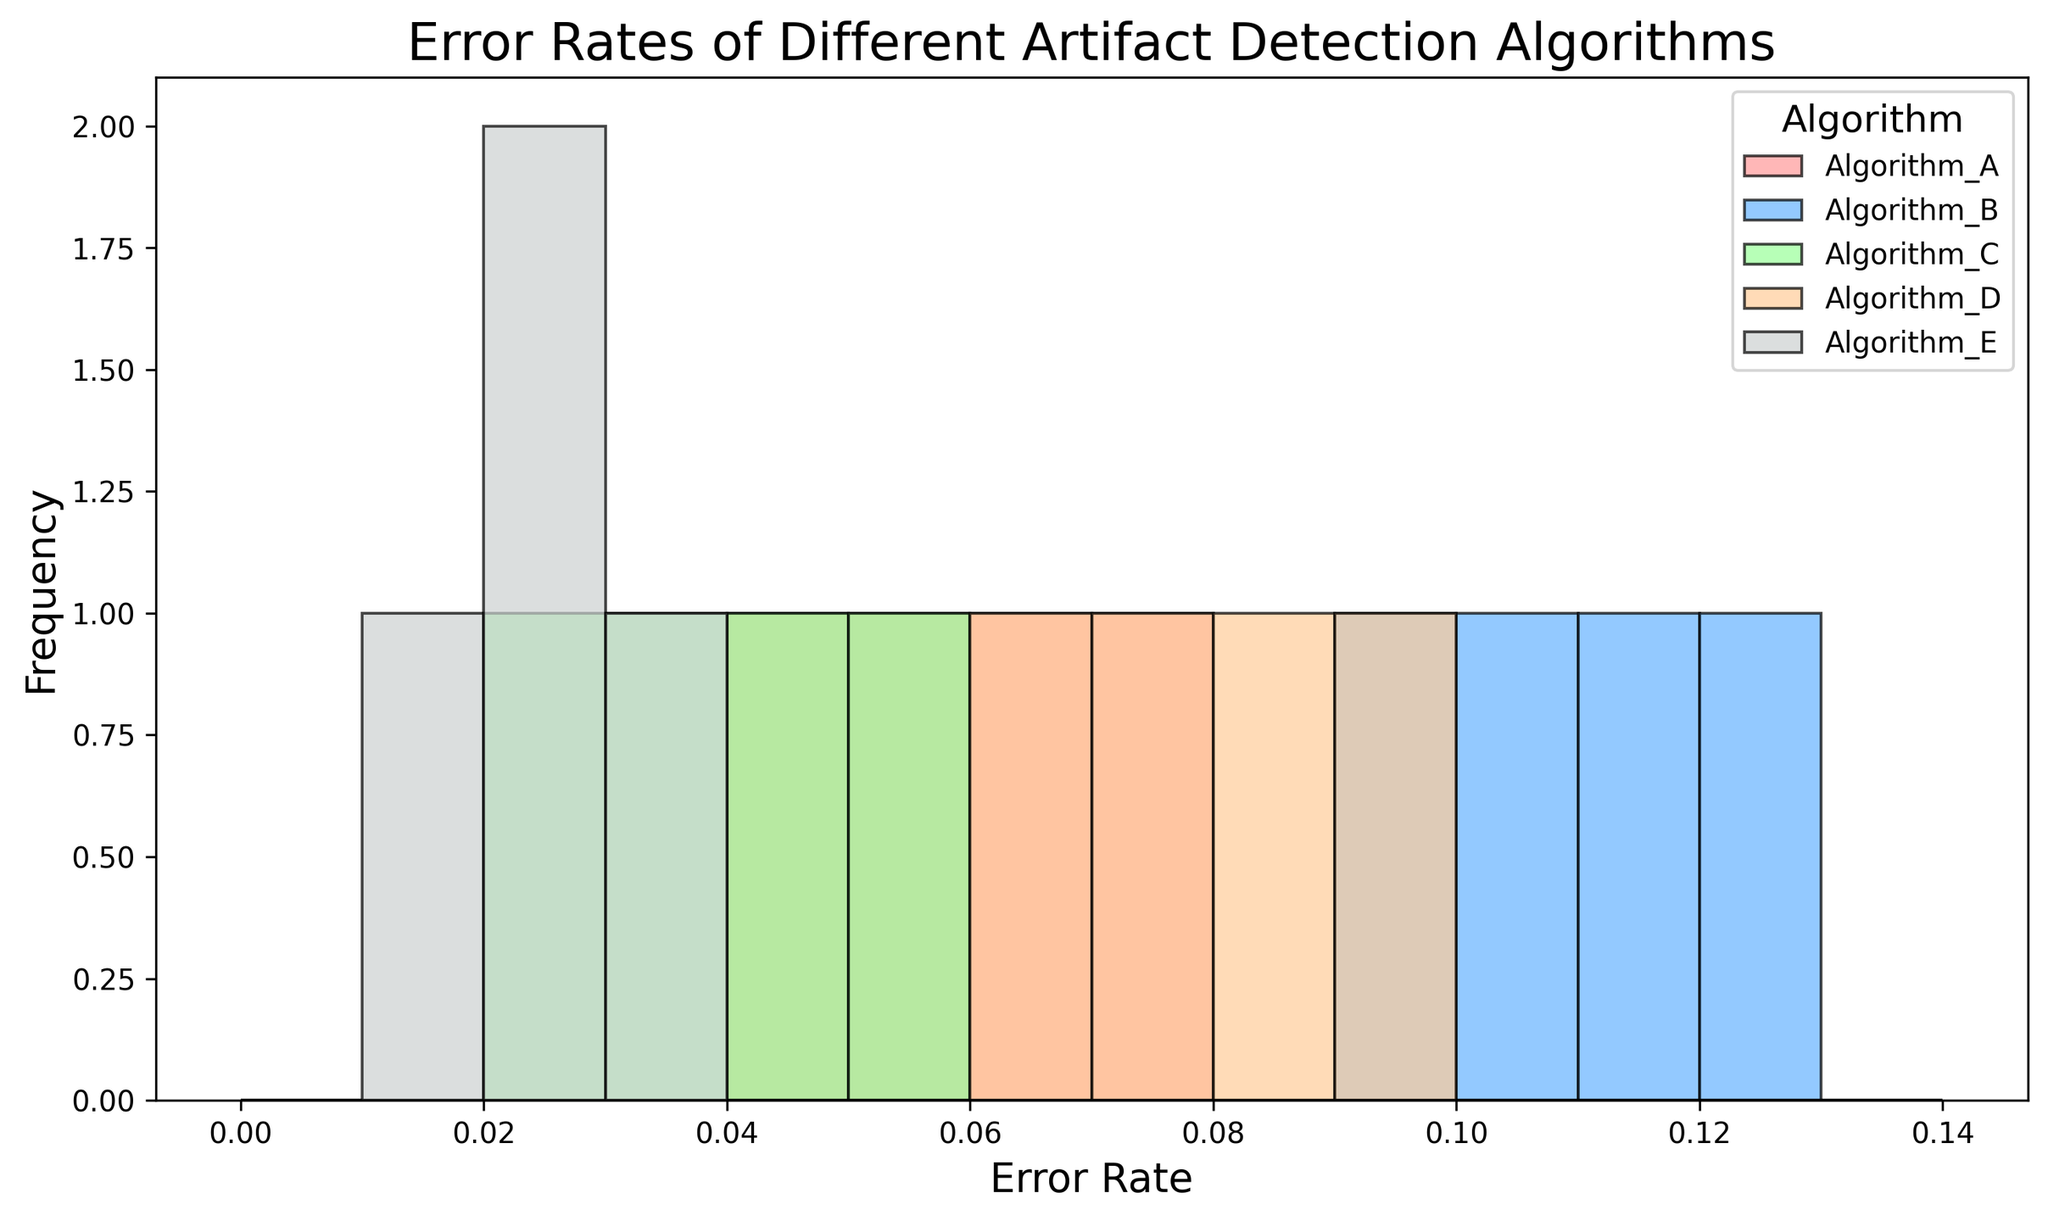Which algorithm shows the highest error rate in the histogram? By analyzing the histogram, Algorithm B has the highest error rate with values around 0.10, 0.09, 0.12, and 0.11, which are the highest among all groups.
Answer: Algorithm B Which algorithm shows the most consistent error rates across different datasets? Examining the bars' lengths within each algorithm, Algorithm E has very consistent error rates, mostly around 0.02 to 0.03, indicating little variation.
Answer: Algorithm E What is the range of error rates for Algorithm D? The histogram for Algorithm D shows error rates ranging from 0.06 to 0.09, as these are the bounds of its values.
Answer: 0.06 to 0.09 Which algorithms have error rates exceeding 0.10? By looking through the histogram, only Algorithm B has error rates that exceed 0.10, specifically reaching up to 0.12.
Answer: Algorithm B How does the error rate of Algorithm A compare to that of Algorithm C in Dataset 4? For Dataset 4, Algorithm A has an error rate of 0.06, while Algorithm C shows an error rate of 0.05. Therefore, Algorithm A has a higher error rate compared to Algorithm C in this dataset.
Answer: Algorithm A is higher Which algorithm has the lowest error rate in any dataset? From the histogram, the lowest error rate observed is 0.01, which belongs to Algorithm E.
Answer: Algorithm E How do the frequencies of error rates around 0.07 compare between Algorithm A and Algorithm D? Algorithm A shows a higher frequency for an error rate around 0.07 compared to Algorithm D, with Algorithm D having 0.07 as its minimum error rate.
Answer: Algorithm A higher What's the average error rate of Algorithm C? Algorithm C has error rates of 0.03, 0.02, 0.04, and 0.05. Summing these gives 0.14, and dividing by the 4 datasets gives an average of 0.035.
Answer: 0.035 Which algorithm has the most variation in error rates across datasets? From a visual inspection, Algorithm B has the most variation, with error rates ranging between 0.09 and 0.12, showing a noticeable spread compared to other algorithms.
Answer: Algorithm B 